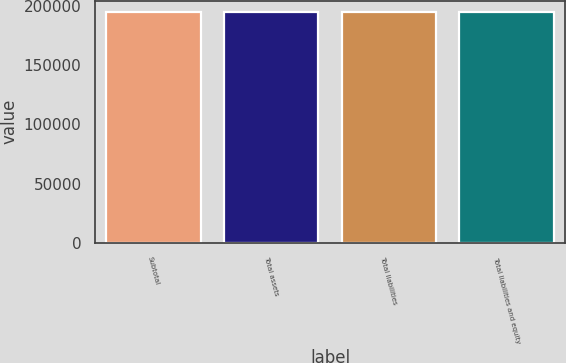<chart> <loc_0><loc_0><loc_500><loc_500><bar_chart><fcel>Subtotal<fcel>Total assets<fcel>Total liabilities<fcel>Total liabilities and equity<nl><fcel>194941<fcel>194941<fcel>194941<fcel>194941<nl></chart> 